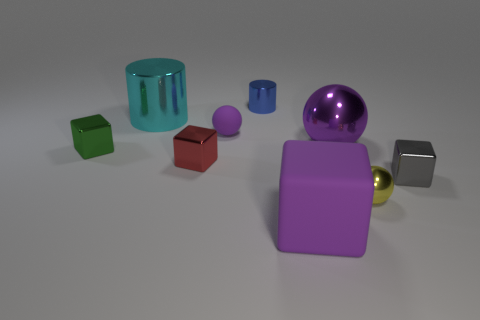Subtract all purple spheres. How many spheres are left? 1 Add 1 small matte objects. How many objects exist? 10 Subtract all purple spheres. How many spheres are left? 1 Subtract 3 spheres. How many spheres are left? 0 Subtract all purple rubber things. Subtract all cyan shiny cylinders. How many objects are left? 6 Add 4 small rubber things. How many small rubber things are left? 5 Add 2 brown rubber spheres. How many brown rubber spheres exist? 2 Subtract 0 red cylinders. How many objects are left? 9 Subtract all balls. How many objects are left? 6 Subtract all red cubes. Subtract all green spheres. How many cubes are left? 3 